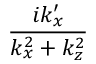<formula> <loc_0><loc_0><loc_500><loc_500>\frac { i k _ { x } ^ { \prime } } { k _ { x } ^ { 2 } + k _ { z } ^ { 2 } }</formula> 